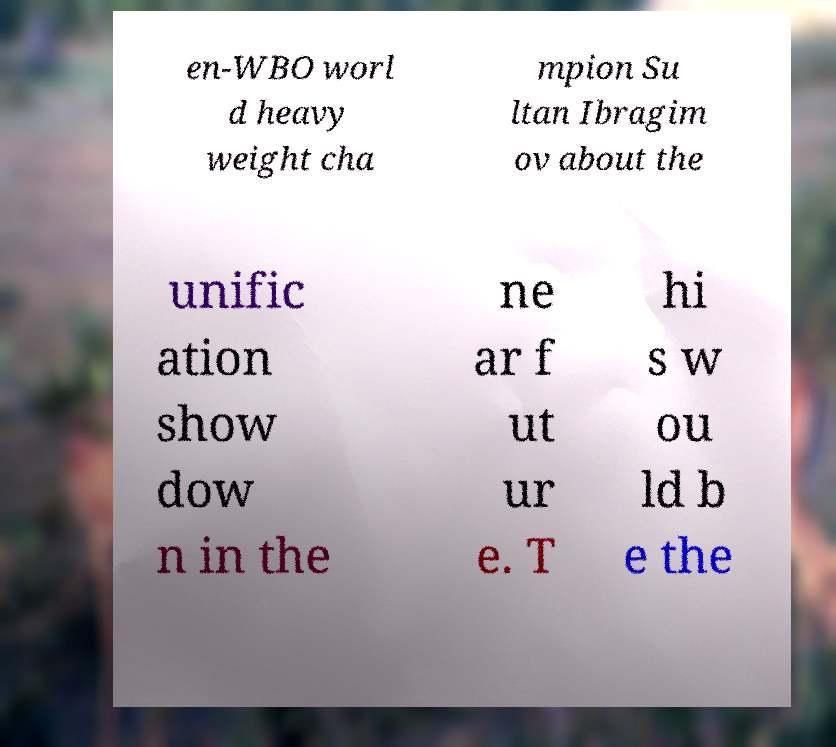Please identify and transcribe the text found in this image. en-WBO worl d heavy weight cha mpion Su ltan Ibragim ov about the unific ation show dow n in the ne ar f ut ur e. T hi s w ou ld b e the 